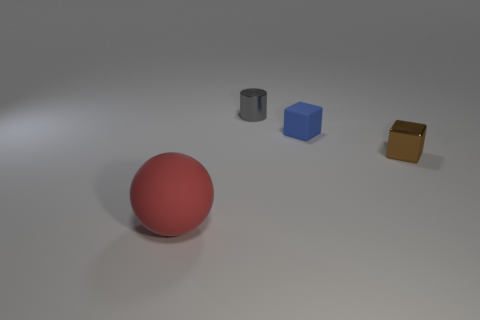What number of balls are either blue matte objects or gray things?
Offer a terse response. 0. What number of small blue cubes have the same material as the brown thing?
Provide a succinct answer. 0. The object that is in front of the matte block and on the right side of the tiny metallic cylinder is made of what material?
Give a very brief answer. Metal. What is the shape of the thing on the left side of the tiny gray thing?
Provide a short and direct response. Sphere. There is a tiny shiny object that is left of the small blue matte thing that is on the right side of the small gray metallic cylinder; what is its shape?
Offer a very short reply. Cylinder. Are there any blue matte objects of the same shape as the gray metallic thing?
Provide a succinct answer. No. What is the shape of the gray metal thing that is the same size as the metallic block?
Your answer should be very brief. Cylinder. Is there a red thing that is behind the cube in front of the matte thing behind the big matte ball?
Your response must be concise. No. Is there a blue rubber cube that has the same size as the shiny block?
Your answer should be compact. Yes. There is a rubber object that is to the left of the tiny blue object; what size is it?
Your response must be concise. Large. 